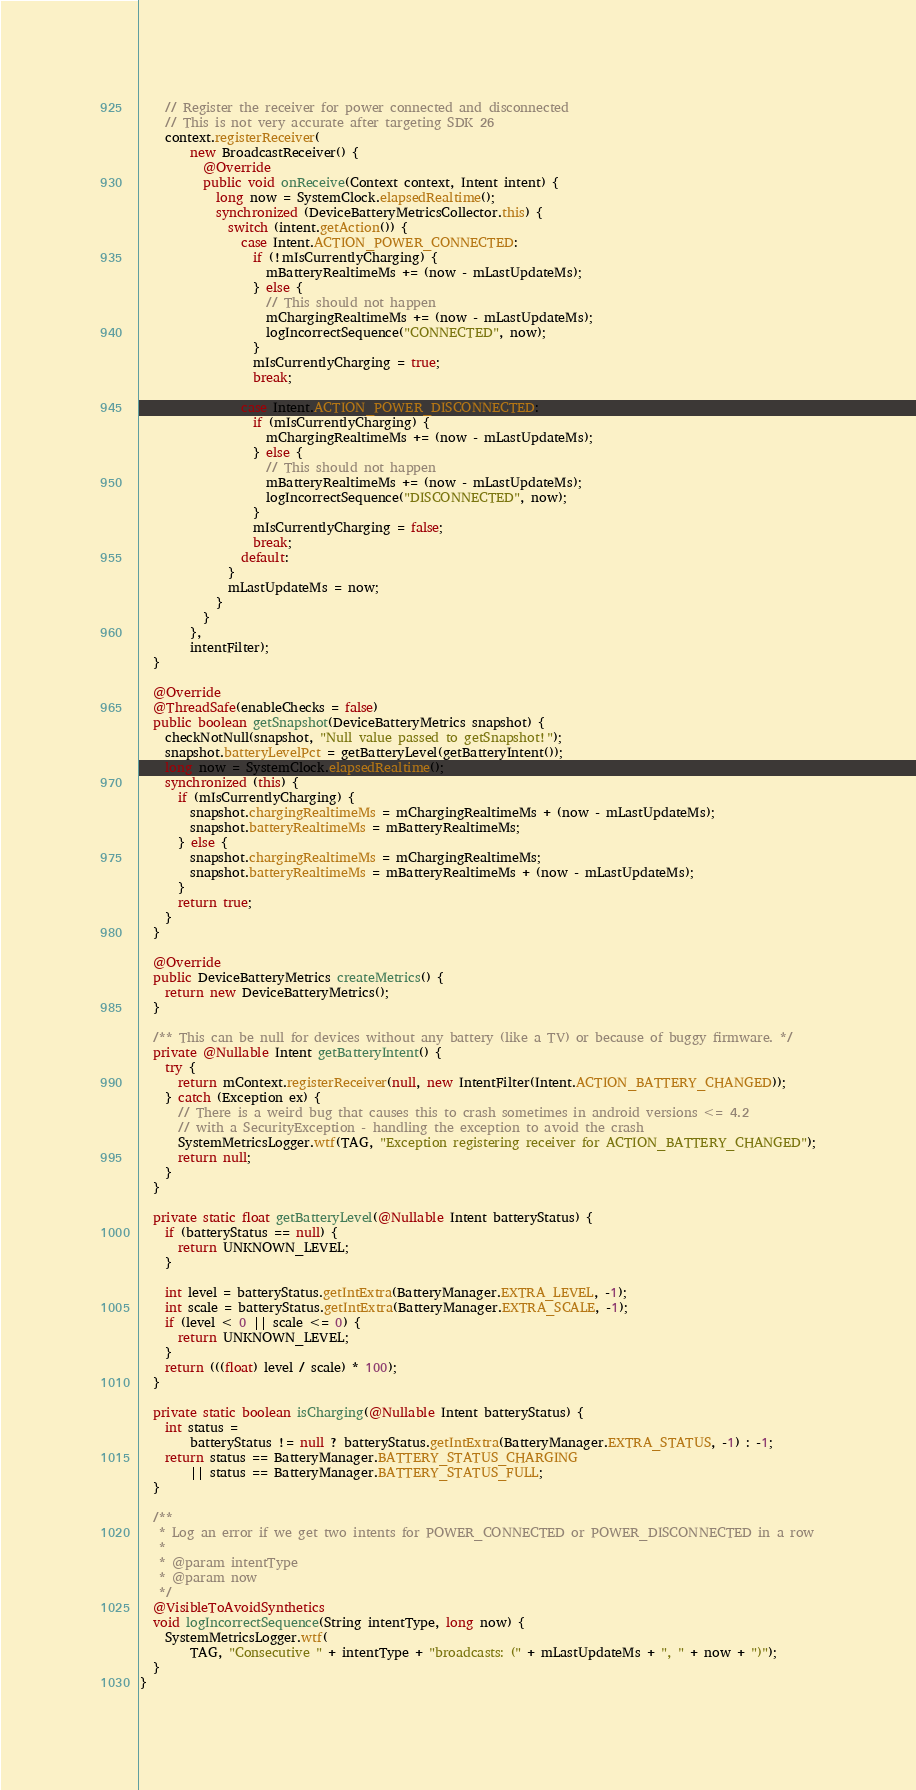Convert code to text. <code><loc_0><loc_0><loc_500><loc_500><_Java_>
    // Register the receiver for power connected and disconnected
    // This is not very accurate after targeting SDK 26
    context.registerReceiver(
        new BroadcastReceiver() {
          @Override
          public void onReceive(Context context, Intent intent) {
            long now = SystemClock.elapsedRealtime();
            synchronized (DeviceBatteryMetricsCollector.this) {
              switch (intent.getAction()) {
                case Intent.ACTION_POWER_CONNECTED:
                  if (!mIsCurrentlyCharging) {
                    mBatteryRealtimeMs += (now - mLastUpdateMs);
                  } else {
                    // This should not happen
                    mChargingRealtimeMs += (now - mLastUpdateMs);
                    logIncorrectSequence("CONNECTED", now);
                  }
                  mIsCurrentlyCharging = true;
                  break;

                case Intent.ACTION_POWER_DISCONNECTED:
                  if (mIsCurrentlyCharging) {
                    mChargingRealtimeMs += (now - mLastUpdateMs);
                  } else {
                    // This should not happen
                    mBatteryRealtimeMs += (now - mLastUpdateMs);
                    logIncorrectSequence("DISCONNECTED", now);
                  }
                  mIsCurrentlyCharging = false;
                  break;
                default:
              }
              mLastUpdateMs = now;
            }
          }
        },
        intentFilter);
  }

  @Override
  @ThreadSafe(enableChecks = false)
  public boolean getSnapshot(DeviceBatteryMetrics snapshot) {
    checkNotNull(snapshot, "Null value passed to getSnapshot!");
    snapshot.batteryLevelPct = getBatteryLevel(getBatteryIntent());
    long now = SystemClock.elapsedRealtime();
    synchronized (this) {
      if (mIsCurrentlyCharging) {
        snapshot.chargingRealtimeMs = mChargingRealtimeMs + (now - mLastUpdateMs);
        snapshot.batteryRealtimeMs = mBatteryRealtimeMs;
      } else {
        snapshot.chargingRealtimeMs = mChargingRealtimeMs;
        snapshot.batteryRealtimeMs = mBatteryRealtimeMs + (now - mLastUpdateMs);
      }
      return true;
    }
  }

  @Override
  public DeviceBatteryMetrics createMetrics() {
    return new DeviceBatteryMetrics();
  }

  /** This can be null for devices without any battery (like a TV) or because of buggy firmware. */
  private @Nullable Intent getBatteryIntent() {
    try {
      return mContext.registerReceiver(null, new IntentFilter(Intent.ACTION_BATTERY_CHANGED));
    } catch (Exception ex) {
      // There is a weird bug that causes this to crash sometimes in android versions <= 4.2
      // with a SecurityException - handling the exception to avoid the crash
      SystemMetricsLogger.wtf(TAG, "Exception registering receiver for ACTION_BATTERY_CHANGED");
      return null;
    }
  }

  private static float getBatteryLevel(@Nullable Intent batteryStatus) {
    if (batteryStatus == null) {
      return UNKNOWN_LEVEL;
    }

    int level = batteryStatus.getIntExtra(BatteryManager.EXTRA_LEVEL, -1);
    int scale = batteryStatus.getIntExtra(BatteryManager.EXTRA_SCALE, -1);
    if (level < 0 || scale <= 0) {
      return UNKNOWN_LEVEL;
    }
    return (((float) level / scale) * 100);
  }

  private static boolean isCharging(@Nullable Intent batteryStatus) {
    int status =
        batteryStatus != null ? batteryStatus.getIntExtra(BatteryManager.EXTRA_STATUS, -1) : -1;
    return status == BatteryManager.BATTERY_STATUS_CHARGING
        || status == BatteryManager.BATTERY_STATUS_FULL;
  }

  /**
   * Log an error if we get two intents for POWER_CONNECTED or POWER_DISCONNECTED in a row
   *
   * @param intentType
   * @param now
   */
  @VisibleToAvoidSynthetics
  void logIncorrectSequence(String intentType, long now) {
    SystemMetricsLogger.wtf(
        TAG, "Consecutive " + intentType + "broadcasts: (" + mLastUpdateMs + ", " + now + ")");
  }
}
</code> 